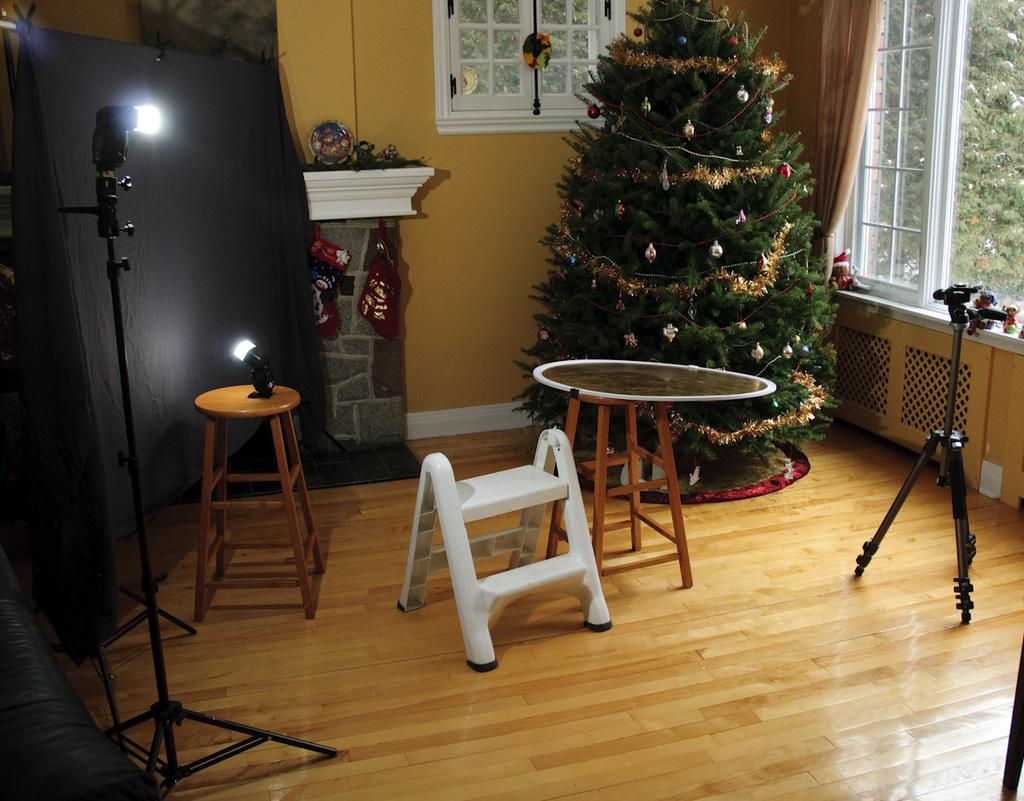What type of furniture is present in the image? There is a table and a stool in the image. What seasonal decoration can be seen in the image? There is a Christmas tree in the image. What else is on the floor in the image besides the stool? There are other objects on the floor in the image. Can you tell me how many potatoes are on the table in the image? There are no potatoes present in the image. What type of art is hanging on the wall in the image? There is no art visible in the image. 